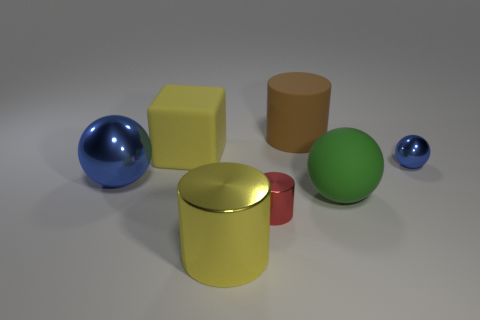What number of shiny things are either small blue balls or tiny red things?
Keep it short and to the point. 2. What is the size of the shiny object on the right side of the small object in front of the small metallic sphere?
Your response must be concise. Small. There is a object that is the same color as the big shiny cylinder; what is it made of?
Provide a short and direct response. Rubber. There is a large cylinder that is behind the blue metallic thing that is on the left side of the tiny metallic ball; are there any metal cylinders behind it?
Give a very brief answer. No. Is the blue ball that is to the right of the big yellow cylinder made of the same material as the blue object that is on the left side of the large rubber cylinder?
Your answer should be very brief. Yes. What number of things are small objects or blue balls on the right side of the matte cylinder?
Offer a terse response. 2. How many big green things have the same shape as the tiny blue object?
Your response must be concise. 1. There is a blue thing that is the same size as the green matte ball; what is its material?
Make the answer very short. Metal. How big is the blue sphere that is left of the metal thing to the right of the small thing that is in front of the large blue object?
Give a very brief answer. Large. Do the big cylinder that is in front of the small blue thing and the rubber block left of the large matte sphere have the same color?
Your response must be concise. Yes. 